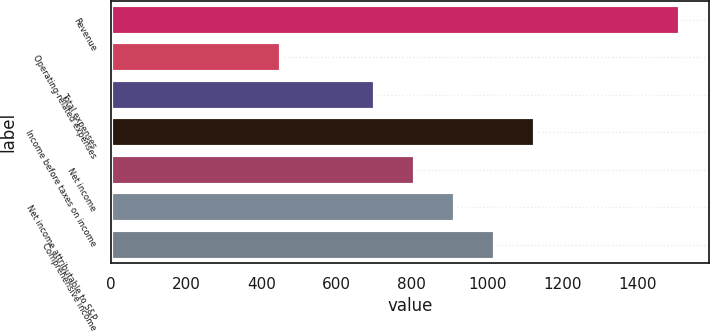Convert chart. <chart><loc_0><loc_0><loc_500><loc_500><bar_chart><fcel>Revenue<fcel>Operating-related expenses<fcel>Total expenses<fcel>Income before taxes on income<fcel>Net income<fcel>Net income attributable to S&P<fcel>Comprehensive income<nl><fcel>1513<fcel>451<fcel>703<fcel>1127.8<fcel>809.2<fcel>915.4<fcel>1021.6<nl></chart> 